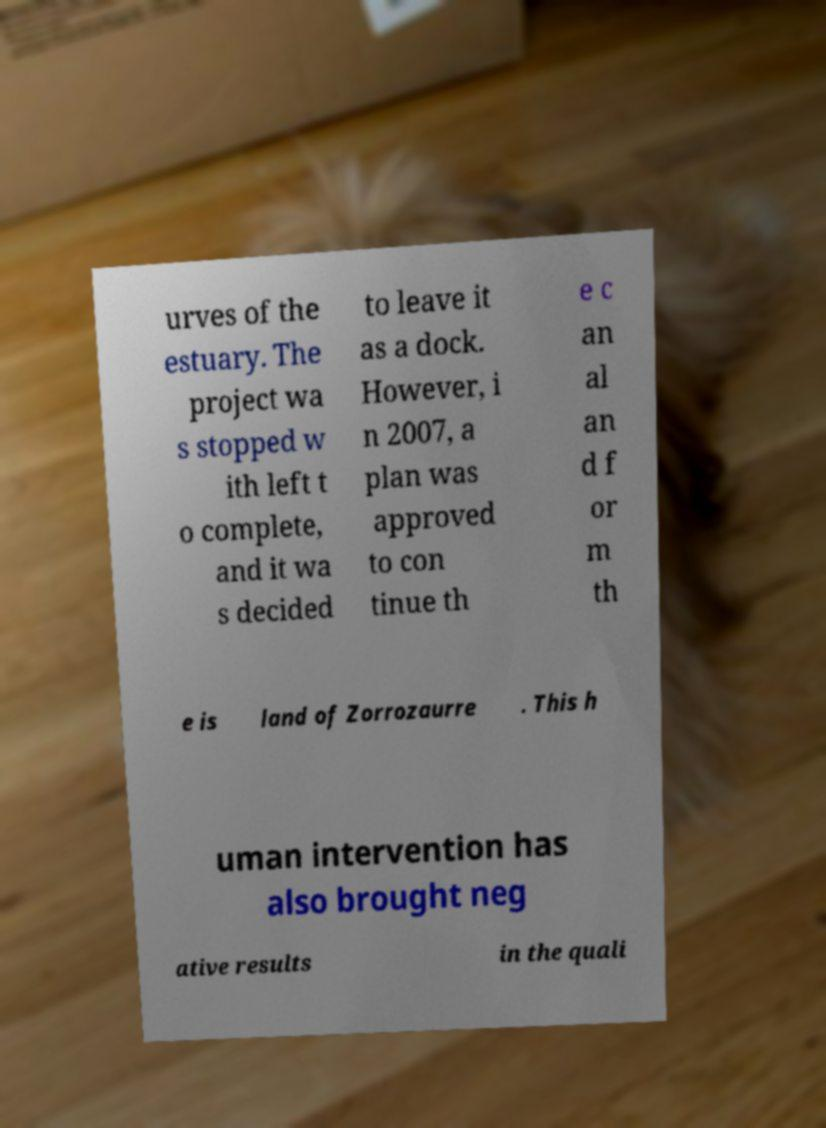Could you extract and type out the text from this image? urves of the estuary. The project wa s stopped w ith left t o complete, and it wa s decided to leave it as a dock. However, i n 2007, a plan was approved to con tinue th e c an al an d f or m th e is land of Zorrozaurre . This h uman intervention has also brought neg ative results in the quali 